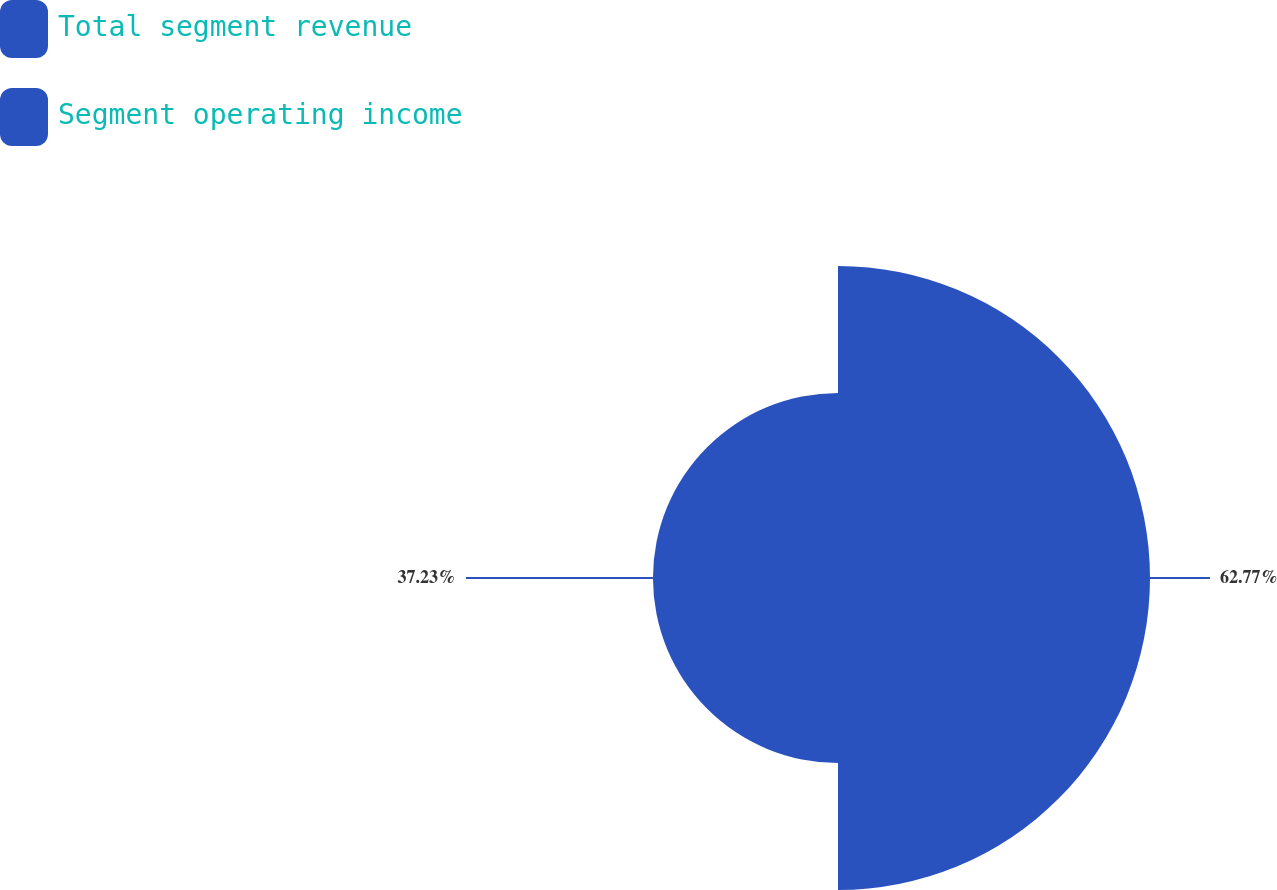Convert chart. <chart><loc_0><loc_0><loc_500><loc_500><pie_chart><fcel>Total segment revenue<fcel>Segment operating income<nl><fcel>62.77%<fcel>37.23%<nl></chart> 